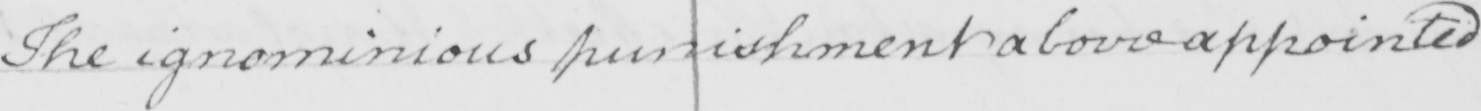Transcribe the text shown in this historical manuscript line. The ignominious punishment above appointed 